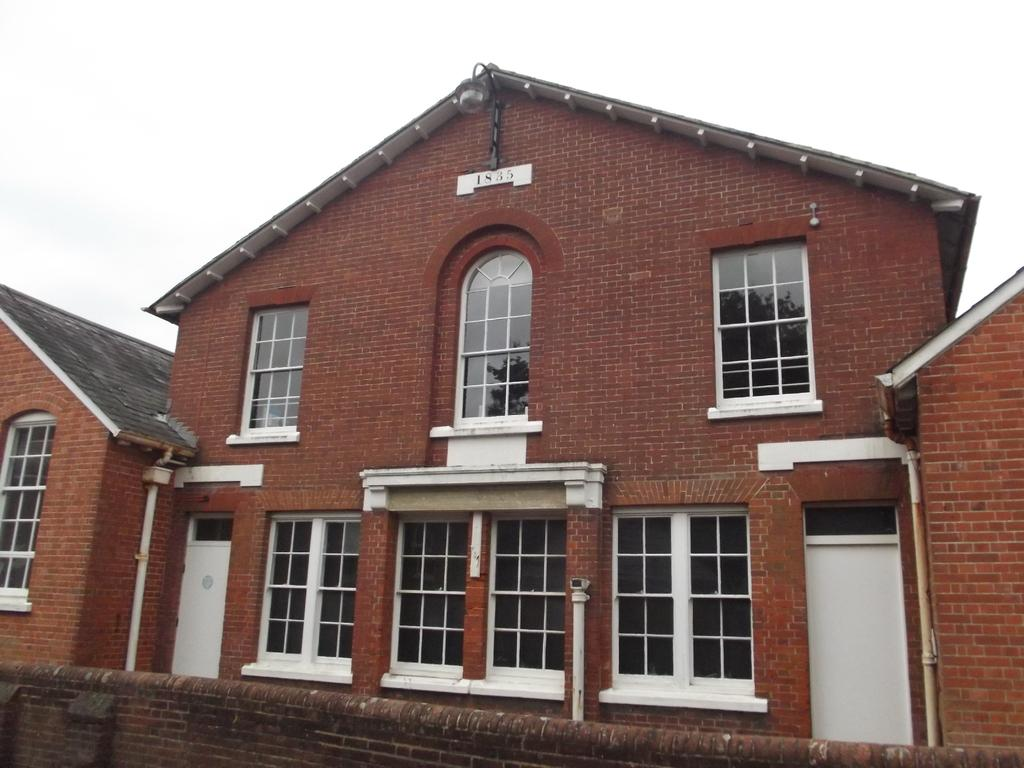What type of structures are present in the image? There are buildings in the image. What colors are the buildings? The buildings are brown and white in color. Can you describe any other color in the image? There is a brown color wall in the image. What is the color of the background in the image? The background of the image is white. Are there any numbers visible in the image? Yes, there are numbers visible in the image. What type of fruit is being flown in the image? There is no fruit or flight present in the image. Can you identify any words written on the buildings in the image? The provided facts do not mention any words written on the buildings, so we cannot answer that question. 